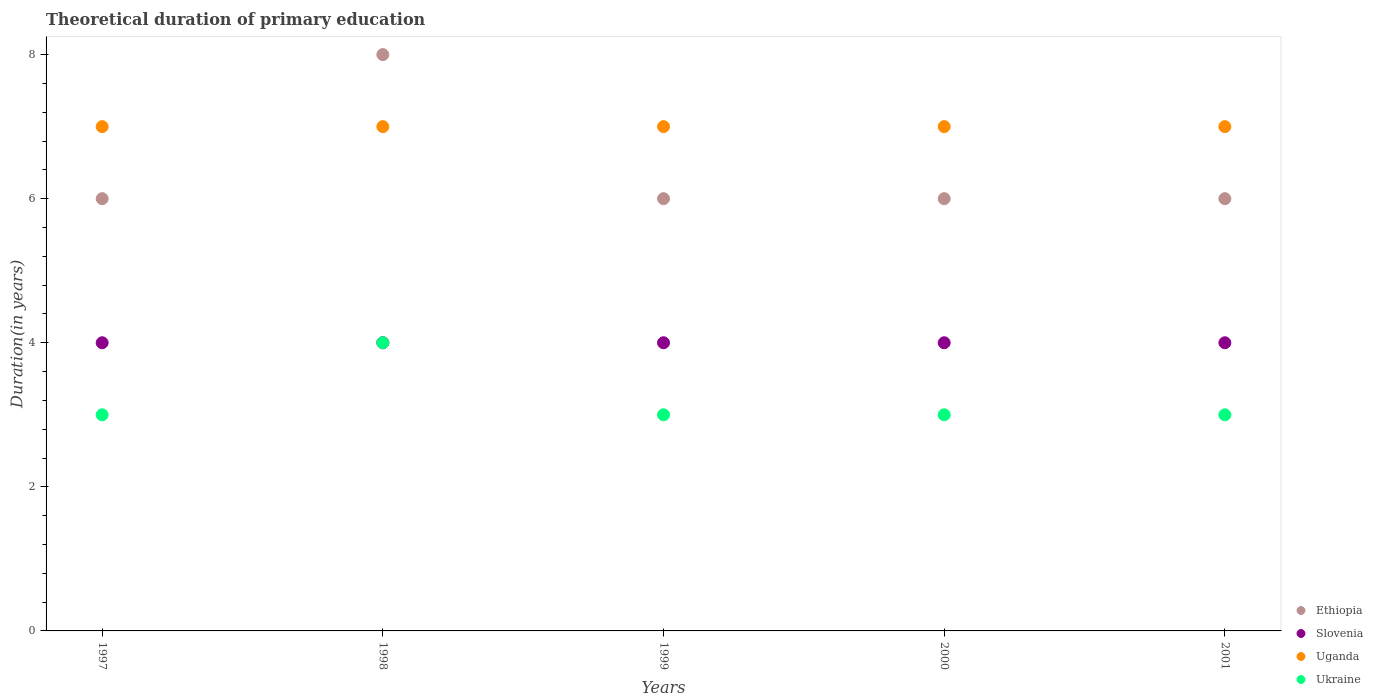What is the total theoretical duration of primary education in Ethiopia in 2000?
Your answer should be compact. 6. Across all years, what is the maximum total theoretical duration of primary education in Ethiopia?
Offer a very short reply. 8. Across all years, what is the minimum total theoretical duration of primary education in Ethiopia?
Your response must be concise. 6. In which year was the total theoretical duration of primary education in Uganda maximum?
Give a very brief answer. 1997. In which year was the total theoretical duration of primary education in Ethiopia minimum?
Give a very brief answer. 1997. What is the total total theoretical duration of primary education in Ukraine in the graph?
Make the answer very short. 16. What is the difference between the total theoretical duration of primary education in Ukraine in 1997 and that in 1999?
Provide a short and direct response. 0. What is the difference between the total theoretical duration of primary education in Uganda in 1997 and the total theoretical duration of primary education in Ethiopia in 1999?
Provide a succinct answer. 1. What is the average total theoretical duration of primary education in Uganda per year?
Provide a succinct answer. 7. In the year 1998, what is the difference between the total theoretical duration of primary education in Ukraine and total theoretical duration of primary education in Uganda?
Offer a terse response. -3. What is the ratio of the total theoretical duration of primary education in Ethiopia in 1998 to that in 1999?
Give a very brief answer. 1.33. Is the total theoretical duration of primary education in Slovenia in 1997 less than that in 1999?
Provide a short and direct response. No. Is the difference between the total theoretical duration of primary education in Ukraine in 1999 and 2000 greater than the difference between the total theoretical duration of primary education in Uganda in 1999 and 2000?
Ensure brevity in your answer.  No. What is the difference between the highest and the second highest total theoretical duration of primary education in Slovenia?
Your answer should be compact. 0. What is the difference between the highest and the lowest total theoretical duration of primary education in Ukraine?
Your answer should be compact. 1. In how many years, is the total theoretical duration of primary education in Slovenia greater than the average total theoretical duration of primary education in Slovenia taken over all years?
Make the answer very short. 0. Is the sum of the total theoretical duration of primary education in Ukraine in 1998 and 1999 greater than the maximum total theoretical duration of primary education in Uganda across all years?
Provide a succinct answer. No. Is it the case that in every year, the sum of the total theoretical duration of primary education in Slovenia and total theoretical duration of primary education in Ukraine  is greater than the sum of total theoretical duration of primary education in Ethiopia and total theoretical duration of primary education in Uganda?
Give a very brief answer. No. Does the total theoretical duration of primary education in Slovenia monotonically increase over the years?
Give a very brief answer. No. Is the total theoretical duration of primary education in Ukraine strictly greater than the total theoretical duration of primary education in Uganda over the years?
Give a very brief answer. No. Is the total theoretical duration of primary education in Ethiopia strictly less than the total theoretical duration of primary education in Uganda over the years?
Ensure brevity in your answer.  No. How many dotlines are there?
Offer a very short reply. 4. Are the values on the major ticks of Y-axis written in scientific E-notation?
Provide a succinct answer. No. Does the graph contain any zero values?
Your response must be concise. No. Where does the legend appear in the graph?
Make the answer very short. Bottom right. How are the legend labels stacked?
Offer a terse response. Vertical. What is the title of the graph?
Provide a succinct answer. Theoretical duration of primary education. Does "Mauritania" appear as one of the legend labels in the graph?
Offer a terse response. No. What is the label or title of the Y-axis?
Provide a short and direct response. Duration(in years). What is the Duration(in years) of Ethiopia in 1997?
Keep it short and to the point. 6. What is the Duration(in years) of Slovenia in 1997?
Give a very brief answer. 4. What is the Duration(in years) of Ethiopia in 1998?
Your answer should be compact. 8. What is the Duration(in years) of Slovenia in 1998?
Your answer should be compact. 4. What is the Duration(in years) of Uganda in 1998?
Your answer should be very brief. 7. What is the Duration(in years) of Ukraine in 1998?
Provide a short and direct response. 4. What is the Duration(in years) of Slovenia in 1999?
Keep it short and to the point. 4. What is the Duration(in years) of Ukraine in 1999?
Provide a short and direct response. 3. What is the Duration(in years) in Ethiopia in 2000?
Make the answer very short. 6. What is the Duration(in years) of Ukraine in 2000?
Give a very brief answer. 3. What is the Duration(in years) in Ethiopia in 2001?
Ensure brevity in your answer.  6. What is the Duration(in years) in Uganda in 2001?
Keep it short and to the point. 7. What is the Duration(in years) of Ukraine in 2001?
Ensure brevity in your answer.  3. Across all years, what is the maximum Duration(in years) of Ethiopia?
Provide a short and direct response. 8. Across all years, what is the minimum Duration(in years) of Slovenia?
Offer a terse response. 4. What is the total Duration(in years) in Uganda in the graph?
Make the answer very short. 35. What is the difference between the Duration(in years) in Ethiopia in 1997 and that in 1998?
Your answer should be compact. -2. What is the difference between the Duration(in years) in Slovenia in 1997 and that in 1998?
Your response must be concise. 0. What is the difference between the Duration(in years) of Ethiopia in 1997 and that in 1999?
Ensure brevity in your answer.  0. What is the difference between the Duration(in years) of Uganda in 1997 and that in 1999?
Keep it short and to the point. 0. What is the difference between the Duration(in years) in Ukraine in 1997 and that in 1999?
Provide a succinct answer. 0. What is the difference between the Duration(in years) in Ethiopia in 1997 and that in 2000?
Provide a succinct answer. 0. What is the difference between the Duration(in years) of Ukraine in 1997 and that in 2000?
Your response must be concise. 0. What is the difference between the Duration(in years) of Ethiopia in 1997 and that in 2001?
Your answer should be very brief. 0. What is the difference between the Duration(in years) of Uganda in 1997 and that in 2001?
Ensure brevity in your answer.  0. What is the difference between the Duration(in years) of Uganda in 1998 and that in 1999?
Keep it short and to the point. 0. What is the difference between the Duration(in years) in Ethiopia in 1998 and that in 2000?
Make the answer very short. 2. What is the difference between the Duration(in years) of Slovenia in 1998 and that in 2000?
Your answer should be very brief. 0. What is the difference between the Duration(in years) in Uganda in 1998 and that in 2000?
Provide a short and direct response. 0. What is the difference between the Duration(in years) in Ukraine in 1998 and that in 2000?
Keep it short and to the point. 1. What is the difference between the Duration(in years) in Ethiopia in 1998 and that in 2001?
Your response must be concise. 2. What is the difference between the Duration(in years) of Uganda in 1998 and that in 2001?
Offer a terse response. 0. What is the difference between the Duration(in years) in Ukraine in 1998 and that in 2001?
Your response must be concise. 1. What is the difference between the Duration(in years) in Ethiopia in 1999 and that in 2000?
Keep it short and to the point. 0. What is the difference between the Duration(in years) in Uganda in 1999 and that in 2000?
Offer a very short reply. 0. What is the difference between the Duration(in years) of Slovenia in 1999 and that in 2001?
Give a very brief answer. 0. What is the difference between the Duration(in years) in Uganda in 1999 and that in 2001?
Offer a very short reply. 0. What is the difference between the Duration(in years) in Ukraine in 1999 and that in 2001?
Ensure brevity in your answer.  0. What is the difference between the Duration(in years) of Ethiopia in 2000 and that in 2001?
Provide a short and direct response. 0. What is the difference between the Duration(in years) of Uganda in 2000 and that in 2001?
Provide a succinct answer. 0. What is the difference between the Duration(in years) of Slovenia in 1997 and the Duration(in years) of Uganda in 1998?
Ensure brevity in your answer.  -3. What is the difference between the Duration(in years) in Slovenia in 1997 and the Duration(in years) in Ukraine in 1998?
Offer a terse response. 0. What is the difference between the Duration(in years) in Ethiopia in 1997 and the Duration(in years) in Uganda in 1999?
Provide a succinct answer. -1. What is the difference between the Duration(in years) of Ethiopia in 1997 and the Duration(in years) of Ukraine in 1999?
Make the answer very short. 3. What is the difference between the Duration(in years) of Slovenia in 1997 and the Duration(in years) of Ukraine in 1999?
Offer a very short reply. 1. What is the difference between the Duration(in years) of Slovenia in 1997 and the Duration(in years) of Uganda in 2001?
Offer a very short reply. -3. What is the difference between the Duration(in years) of Slovenia in 1997 and the Duration(in years) of Ukraine in 2001?
Ensure brevity in your answer.  1. What is the difference between the Duration(in years) of Uganda in 1997 and the Duration(in years) of Ukraine in 2001?
Keep it short and to the point. 4. What is the difference between the Duration(in years) of Ethiopia in 1998 and the Duration(in years) of Uganda in 1999?
Make the answer very short. 1. What is the difference between the Duration(in years) of Ethiopia in 1998 and the Duration(in years) of Ukraine in 1999?
Offer a very short reply. 5. What is the difference between the Duration(in years) of Ethiopia in 1998 and the Duration(in years) of Slovenia in 2000?
Your answer should be very brief. 4. What is the difference between the Duration(in years) in Slovenia in 1998 and the Duration(in years) in Uganda in 2000?
Keep it short and to the point. -3. What is the difference between the Duration(in years) of Ethiopia in 1998 and the Duration(in years) of Slovenia in 2001?
Your response must be concise. 4. What is the difference between the Duration(in years) of Ethiopia in 1998 and the Duration(in years) of Ukraine in 2001?
Your response must be concise. 5. What is the difference between the Duration(in years) of Slovenia in 1998 and the Duration(in years) of Uganda in 2001?
Give a very brief answer. -3. What is the difference between the Duration(in years) in Slovenia in 1998 and the Duration(in years) in Ukraine in 2001?
Ensure brevity in your answer.  1. What is the difference between the Duration(in years) in Uganda in 1998 and the Duration(in years) in Ukraine in 2001?
Keep it short and to the point. 4. What is the difference between the Duration(in years) of Ethiopia in 1999 and the Duration(in years) of Ukraine in 2000?
Offer a very short reply. 3. What is the difference between the Duration(in years) in Slovenia in 1999 and the Duration(in years) in Uganda in 2000?
Your answer should be very brief. -3. What is the difference between the Duration(in years) in Uganda in 1999 and the Duration(in years) in Ukraine in 2000?
Provide a succinct answer. 4. What is the difference between the Duration(in years) of Uganda in 1999 and the Duration(in years) of Ukraine in 2001?
Offer a terse response. 4. What is the difference between the Duration(in years) of Ethiopia in 2000 and the Duration(in years) of Slovenia in 2001?
Provide a succinct answer. 2. What is the difference between the Duration(in years) of Ethiopia in 2000 and the Duration(in years) of Uganda in 2001?
Keep it short and to the point. -1. What is the difference between the Duration(in years) of Ethiopia in 2000 and the Duration(in years) of Ukraine in 2001?
Offer a very short reply. 3. What is the difference between the Duration(in years) in Slovenia in 2000 and the Duration(in years) in Uganda in 2001?
Ensure brevity in your answer.  -3. What is the difference between the Duration(in years) of Slovenia in 2000 and the Duration(in years) of Ukraine in 2001?
Keep it short and to the point. 1. What is the average Duration(in years) of Ethiopia per year?
Keep it short and to the point. 6.4. What is the average Duration(in years) of Uganda per year?
Ensure brevity in your answer.  7. In the year 1997, what is the difference between the Duration(in years) of Ethiopia and Duration(in years) of Uganda?
Keep it short and to the point. -1. In the year 1997, what is the difference between the Duration(in years) in Ethiopia and Duration(in years) in Ukraine?
Make the answer very short. 3. In the year 1997, what is the difference between the Duration(in years) of Slovenia and Duration(in years) of Ukraine?
Give a very brief answer. 1. In the year 1997, what is the difference between the Duration(in years) of Uganda and Duration(in years) of Ukraine?
Your answer should be very brief. 4. In the year 1998, what is the difference between the Duration(in years) of Ethiopia and Duration(in years) of Slovenia?
Keep it short and to the point. 4. In the year 1998, what is the difference between the Duration(in years) of Ethiopia and Duration(in years) of Ukraine?
Ensure brevity in your answer.  4. In the year 1998, what is the difference between the Duration(in years) of Slovenia and Duration(in years) of Uganda?
Give a very brief answer. -3. In the year 1998, what is the difference between the Duration(in years) in Uganda and Duration(in years) in Ukraine?
Provide a short and direct response. 3. In the year 1999, what is the difference between the Duration(in years) in Ethiopia and Duration(in years) in Slovenia?
Your response must be concise. 2. In the year 1999, what is the difference between the Duration(in years) in Ethiopia and Duration(in years) in Uganda?
Provide a short and direct response. -1. In the year 1999, what is the difference between the Duration(in years) in Ethiopia and Duration(in years) in Ukraine?
Provide a short and direct response. 3. In the year 1999, what is the difference between the Duration(in years) of Slovenia and Duration(in years) of Uganda?
Give a very brief answer. -3. In the year 2000, what is the difference between the Duration(in years) in Ethiopia and Duration(in years) in Slovenia?
Provide a short and direct response. 2. In the year 2000, what is the difference between the Duration(in years) of Ethiopia and Duration(in years) of Uganda?
Offer a very short reply. -1. In the year 2000, what is the difference between the Duration(in years) in Slovenia and Duration(in years) in Uganda?
Offer a terse response. -3. In the year 2001, what is the difference between the Duration(in years) in Ethiopia and Duration(in years) in Slovenia?
Provide a short and direct response. 2. In the year 2001, what is the difference between the Duration(in years) in Ethiopia and Duration(in years) in Ukraine?
Provide a succinct answer. 3. In the year 2001, what is the difference between the Duration(in years) in Uganda and Duration(in years) in Ukraine?
Offer a very short reply. 4. What is the ratio of the Duration(in years) in Ethiopia in 1997 to that in 1998?
Ensure brevity in your answer.  0.75. What is the ratio of the Duration(in years) in Slovenia in 1997 to that in 1998?
Your response must be concise. 1. What is the ratio of the Duration(in years) of Uganda in 1997 to that in 1998?
Provide a short and direct response. 1. What is the ratio of the Duration(in years) of Ukraine in 1997 to that in 1998?
Make the answer very short. 0.75. What is the ratio of the Duration(in years) of Ethiopia in 1997 to that in 1999?
Your answer should be very brief. 1. What is the ratio of the Duration(in years) of Uganda in 1997 to that in 1999?
Provide a succinct answer. 1. What is the ratio of the Duration(in years) of Ukraine in 1997 to that in 1999?
Provide a succinct answer. 1. What is the ratio of the Duration(in years) in Ethiopia in 1997 to that in 2000?
Ensure brevity in your answer.  1. What is the ratio of the Duration(in years) in Slovenia in 1997 to that in 2000?
Make the answer very short. 1. What is the ratio of the Duration(in years) of Ethiopia in 1997 to that in 2001?
Keep it short and to the point. 1. What is the ratio of the Duration(in years) in Uganda in 1997 to that in 2001?
Make the answer very short. 1. What is the ratio of the Duration(in years) of Ukraine in 1997 to that in 2001?
Your response must be concise. 1. What is the ratio of the Duration(in years) in Slovenia in 1998 to that in 1999?
Ensure brevity in your answer.  1. What is the ratio of the Duration(in years) in Ethiopia in 1998 to that in 2000?
Offer a terse response. 1.33. What is the ratio of the Duration(in years) in Slovenia in 1998 to that in 2001?
Your response must be concise. 1. What is the ratio of the Duration(in years) of Ukraine in 1998 to that in 2001?
Provide a succinct answer. 1.33. What is the ratio of the Duration(in years) in Slovenia in 1999 to that in 2000?
Your answer should be compact. 1. What is the ratio of the Duration(in years) in Uganda in 1999 to that in 2000?
Provide a short and direct response. 1. What is the ratio of the Duration(in years) in Ukraine in 2000 to that in 2001?
Make the answer very short. 1. What is the difference between the highest and the second highest Duration(in years) in Ethiopia?
Ensure brevity in your answer.  2. What is the difference between the highest and the second highest Duration(in years) in Uganda?
Provide a short and direct response. 0. What is the difference between the highest and the second highest Duration(in years) of Ukraine?
Your answer should be very brief. 1. What is the difference between the highest and the lowest Duration(in years) in Slovenia?
Keep it short and to the point. 0. What is the difference between the highest and the lowest Duration(in years) of Uganda?
Provide a succinct answer. 0. 